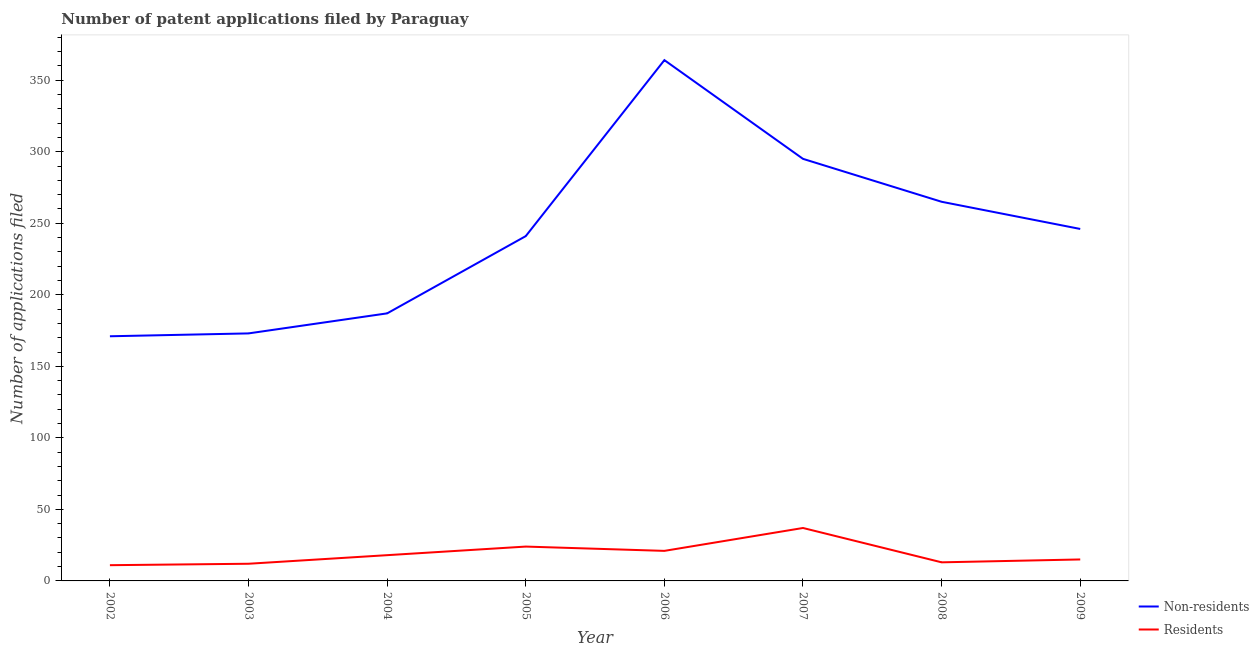What is the number of patent applications by residents in 2009?
Give a very brief answer. 15. Across all years, what is the maximum number of patent applications by non residents?
Provide a succinct answer. 364. Across all years, what is the minimum number of patent applications by non residents?
Offer a very short reply. 171. What is the total number of patent applications by residents in the graph?
Provide a short and direct response. 151. What is the difference between the number of patent applications by residents in 2002 and that in 2005?
Ensure brevity in your answer.  -13. What is the difference between the number of patent applications by non residents in 2006 and the number of patent applications by residents in 2005?
Give a very brief answer. 340. What is the average number of patent applications by residents per year?
Keep it short and to the point. 18.88. In the year 2003, what is the difference between the number of patent applications by residents and number of patent applications by non residents?
Your answer should be very brief. -161. In how many years, is the number of patent applications by residents greater than 140?
Your answer should be compact. 0. What is the ratio of the number of patent applications by residents in 2004 to that in 2006?
Offer a very short reply. 0.86. Is the difference between the number of patent applications by non residents in 2005 and 2006 greater than the difference between the number of patent applications by residents in 2005 and 2006?
Keep it short and to the point. No. What is the difference between the highest and the lowest number of patent applications by non residents?
Keep it short and to the point. 193. Does the number of patent applications by non residents monotonically increase over the years?
Offer a very short reply. No. Is the number of patent applications by non residents strictly greater than the number of patent applications by residents over the years?
Your answer should be compact. Yes. Is the number of patent applications by residents strictly less than the number of patent applications by non residents over the years?
Ensure brevity in your answer.  Yes. How many years are there in the graph?
Provide a short and direct response. 8. What is the difference between two consecutive major ticks on the Y-axis?
Provide a short and direct response. 50. How are the legend labels stacked?
Your answer should be very brief. Vertical. What is the title of the graph?
Give a very brief answer. Number of patent applications filed by Paraguay. What is the label or title of the X-axis?
Your answer should be compact. Year. What is the label or title of the Y-axis?
Ensure brevity in your answer.  Number of applications filed. What is the Number of applications filed in Non-residents in 2002?
Offer a very short reply. 171. What is the Number of applications filed of Non-residents in 2003?
Your response must be concise. 173. What is the Number of applications filed of Non-residents in 2004?
Ensure brevity in your answer.  187. What is the Number of applications filed of Non-residents in 2005?
Your response must be concise. 241. What is the Number of applications filed in Non-residents in 2006?
Give a very brief answer. 364. What is the Number of applications filed in Non-residents in 2007?
Keep it short and to the point. 295. What is the Number of applications filed in Residents in 2007?
Make the answer very short. 37. What is the Number of applications filed in Non-residents in 2008?
Your answer should be very brief. 265. What is the Number of applications filed in Residents in 2008?
Keep it short and to the point. 13. What is the Number of applications filed of Non-residents in 2009?
Your response must be concise. 246. Across all years, what is the maximum Number of applications filed in Non-residents?
Offer a terse response. 364. Across all years, what is the minimum Number of applications filed of Non-residents?
Give a very brief answer. 171. What is the total Number of applications filed in Non-residents in the graph?
Make the answer very short. 1942. What is the total Number of applications filed of Residents in the graph?
Provide a short and direct response. 151. What is the difference between the Number of applications filed in Non-residents in 2002 and that in 2003?
Provide a succinct answer. -2. What is the difference between the Number of applications filed of Residents in 2002 and that in 2003?
Ensure brevity in your answer.  -1. What is the difference between the Number of applications filed of Non-residents in 2002 and that in 2004?
Offer a terse response. -16. What is the difference between the Number of applications filed in Non-residents in 2002 and that in 2005?
Provide a short and direct response. -70. What is the difference between the Number of applications filed in Residents in 2002 and that in 2005?
Keep it short and to the point. -13. What is the difference between the Number of applications filed in Non-residents in 2002 and that in 2006?
Keep it short and to the point. -193. What is the difference between the Number of applications filed of Non-residents in 2002 and that in 2007?
Your answer should be compact. -124. What is the difference between the Number of applications filed of Non-residents in 2002 and that in 2008?
Offer a terse response. -94. What is the difference between the Number of applications filed in Residents in 2002 and that in 2008?
Provide a succinct answer. -2. What is the difference between the Number of applications filed in Non-residents in 2002 and that in 2009?
Your answer should be very brief. -75. What is the difference between the Number of applications filed of Residents in 2002 and that in 2009?
Your answer should be very brief. -4. What is the difference between the Number of applications filed of Residents in 2003 and that in 2004?
Offer a terse response. -6. What is the difference between the Number of applications filed of Non-residents in 2003 and that in 2005?
Provide a short and direct response. -68. What is the difference between the Number of applications filed of Non-residents in 2003 and that in 2006?
Offer a very short reply. -191. What is the difference between the Number of applications filed of Non-residents in 2003 and that in 2007?
Your answer should be very brief. -122. What is the difference between the Number of applications filed in Non-residents in 2003 and that in 2008?
Your answer should be very brief. -92. What is the difference between the Number of applications filed in Non-residents in 2003 and that in 2009?
Your response must be concise. -73. What is the difference between the Number of applications filed of Non-residents in 2004 and that in 2005?
Make the answer very short. -54. What is the difference between the Number of applications filed in Residents in 2004 and that in 2005?
Offer a very short reply. -6. What is the difference between the Number of applications filed in Non-residents in 2004 and that in 2006?
Ensure brevity in your answer.  -177. What is the difference between the Number of applications filed of Non-residents in 2004 and that in 2007?
Ensure brevity in your answer.  -108. What is the difference between the Number of applications filed in Residents in 2004 and that in 2007?
Your answer should be compact. -19. What is the difference between the Number of applications filed in Non-residents in 2004 and that in 2008?
Provide a short and direct response. -78. What is the difference between the Number of applications filed of Residents in 2004 and that in 2008?
Provide a short and direct response. 5. What is the difference between the Number of applications filed of Non-residents in 2004 and that in 2009?
Offer a terse response. -59. What is the difference between the Number of applications filed of Non-residents in 2005 and that in 2006?
Keep it short and to the point. -123. What is the difference between the Number of applications filed in Non-residents in 2005 and that in 2007?
Keep it short and to the point. -54. What is the difference between the Number of applications filed of Residents in 2005 and that in 2007?
Offer a terse response. -13. What is the difference between the Number of applications filed in Non-residents in 2005 and that in 2008?
Ensure brevity in your answer.  -24. What is the difference between the Number of applications filed of Residents in 2005 and that in 2008?
Provide a short and direct response. 11. What is the difference between the Number of applications filed in Residents in 2005 and that in 2009?
Offer a very short reply. 9. What is the difference between the Number of applications filed in Non-residents in 2006 and that in 2007?
Keep it short and to the point. 69. What is the difference between the Number of applications filed in Non-residents in 2006 and that in 2008?
Ensure brevity in your answer.  99. What is the difference between the Number of applications filed in Non-residents in 2006 and that in 2009?
Offer a very short reply. 118. What is the difference between the Number of applications filed in Non-residents in 2007 and that in 2009?
Offer a very short reply. 49. What is the difference between the Number of applications filed in Non-residents in 2008 and that in 2009?
Offer a terse response. 19. What is the difference between the Number of applications filed in Residents in 2008 and that in 2009?
Provide a succinct answer. -2. What is the difference between the Number of applications filed of Non-residents in 2002 and the Number of applications filed of Residents in 2003?
Your answer should be very brief. 159. What is the difference between the Number of applications filed of Non-residents in 2002 and the Number of applications filed of Residents in 2004?
Provide a succinct answer. 153. What is the difference between the Number of applications filed in Non-residents in 2002 and the Number of applications filed in Residents in 2005?
Your answer should be very brief. 147. What is the difference between the Number of applications filed in Non-residents in 2002 and the Number of applications filed in Residents in 2006?
Make the answer very short. 150. What is the difference between the Number of applications filed in Non-residents in 2002 and the Number of applications filed in Residents in 2007?
Your answer should be compact. 134. What is the difference between the Number of applications filed in Non-residents in 2002 and the Number of applications filed in Residents in 2008?
Offer a terse response. 158. What is the difference between the Number of applications filed in Non-residents in 2002 and the Number of applications filed in Residents in 2009?
Your answer should be very brief. 156. What is the difference between the Number of applications filed of Non-residents in 2003 and the Number of applications filed of Residents in 2004?
Make the answer very short. 155. What is the difference between the Number of applications filed in Non-residents in 2003 and the Number of applications filed in Residents in 2005?
Give a very brief answer. 149. What is the difference between the Number of applications filed of Non-residents in 2003 and the Number of applications filed of Residents in 2006?
Provide a short and direct response. 152. What is the difference between the Number of applications filed of Non-residents in 2003 and the Number of applications filed of Residents in 2007?
Your response must be concise. 136. What is the difference between the Number of applications filed in Non-residents in 2003 and the Number of applications filed in Residents in 2008?
Offer a very short reply. 160. What is the difference between the Number of applications filed in Non-residents in 2003 and the Number of applications filed in Residents in 2009?
Keep it short and to the point. 158. What is the difference between the Number of applications filed in Non-residents in 2004 and the Number of applications filed in Residents in 2005?
Your response must be concise. 163. What is the difference between the Number of applications filed of Non-residents in 2004 and the Number of applications filed of Residents in 2006?
Provide a short and direct response. 166. What is the difference between the Number of applications filed of Non-residents in 2004 and the Number of applications filed of Residents in 2007?
Give a very brief answer. 150. What is the difference between the Number of applications filed in Non-residents in 2004 and the Number of applications filed in Residents in 2008?
Give a very brief answer. 174. What is the difference between the Number of applications filed in Non-residents in 2004 and the Number of applications filed in Residents in 2009?
Provide a short and direct response. 172. What is the difference between the Number of applications filed of Non-residents in 2005 and the Number of applications filed of Residents in 2006?
Your response must be concise. 220. What is the difference between the Number of applications filed of Non-residents in 2005 and the Number of applications filed of Residents in 2007?
Make the answer very short. 204. What is the difference between the Number of applications filed of Non-residents in 2005 and the Number of applications filed of Residents in 2008?
Provide a succinct answer. 228. What is the difference between the Number of applications filed in Non-residents in 2005 and the Number of applications filed in Residents in 2009?
Make the answer very short. 226. What is the difference between the Number of applications filed in Non-residents in 2006 and the Number of applications filed in Residents in 2007?
Your response must be concise. 327. What is the difference between the Number of applications filed in Non-residents in 2006 and the Number of applications filed in Residents in 2008?
Your response must be concise. 351. What is the difference between the Number of applications filed in Non-residents in 2006 and the Number of applications filed in Residents in 2009?
Provide a short and direct response. 349. What is the difference between the Number of applications filed in Non-residents in 2007 and the Number of applications filed in Residents in 2008?
Make the answer very short. 282. What is the difference between the Number of applications filed in Non-residents in 2007 and the Number of applications filed in Residents in 2009?
Give a very brief answer. 280. What is the difference between the Number of applications filed of Non-residents in 2008 and the Number of applications filed of Residents in 2009?
Make the answer very short. 250. What is the average Number of applications filed in Non-residents per year?
Ensure brevity in your answer.  242.75. What is the average Number of applications filed in Residents per year?
Provide a succinct answer. 18.88. In the year 2002, what is the difference between the Number of applications filed in Non-residents and Number of applications filed in Residents?
Your response must be concise. 160. In the year 2003, what is the difference between the Number of applications filed in Non-residents and Number of applications filed in Residents?
Your answer should be very brief. 161. In the year 2004, what is the difference between the Number of applications filed in Non-residents and Number of applications filed in Residents?
Provide a short and direct response. 169. In the year 2005, what is the difference between the Number of applications filed of Non-residents and Number of applications filed of Residents?
Ensure brevity in your answer.  217. In the year 2006, what is the difference between the Number of applications filed in Non-residents and Number of applications filed in Residents?
Your response must be concise. 343. In the year 2007, what is the difference between the Number of applications filed of Non-residents and Number of applications filed of Residents?
Your answer should be very brief. 258. In the year 2008, what is the difference between the Number of applications filed of Non-residents and Number of applications filed of Residents?
Give a very brief answer. 252. In the year 2009, what is the difference between the Number of applications filed in Non-residents and Number of applications filed in Residents?
Your answer should be compact. 231. What is the ratio of the Number of applications filed in Non-residents in 2002 to that in 2003?
Your answer should be very brief. 0.99. What is the ratio of the Number of applications filed in Non-residents in 2002 to that in 2004?
Offer a terse response. 0.91. What is the ratio of the Number of applications filed of Residents in 2002 to that in 2004?
Provide a succinct answer. 0.61. What is the ratio of the Number of applications filed in Non-residents in 2002 to that in 2005?
Offer a very short reply. 0.71. What is the ratio of the Number of applications filed of Residents in 2002 to that in 2005?
Your answer should be compact. 0.46. What is the ratio of the Number of applications filed in Non-residents in 2002 to that in 2006?
Your answer should be very brief. 0.47. What is the ratio of the Number of applications filed in Residents in 2002 to that in 2006?
Give a very brief answer. 0.52. What is the ratio of the Number of applications filed in Non-residents in 2002 to that in 2007?
Offer a terse response. 0.58. What is the ratio of the Number of applications filed of Residents in 2002 to that in 2007?
Offer a very short reply. 0.3. What is the ratio of the Number of applications filed of Non-residents in 2002 to that in 2008?
Your answer should be very brief. 0.65. What is the ratio of the Number of applications filed in Residents in 2002 to that in 2008?
Give a very brief answer. 0.85. What is the ratio of the Number of applications filed in Non-residents in 2002 to that in 2009?
Your answer should be compact. 0.7. What is the ratio of the Number of applications filed of Residents in 2002 to that in 2009?
Keep it short and to the point. 0.73. What is the ratio of the Number of applications filed in Non-residents in 2003 to that in 2004?
Provide a succinct answer. 0.93. What is the ratio of the Number of applications filed of Non-residents in 2003 to that in 2005?
Make the answer very short. 0.72. What is the ratio of the Number of applications filed in Residents in 2003 to that in 2005?
Your answer should be compact. 0.5. What is the ratio of the Number of applications filed in Non-residents in 2003 to that in 2006?
Offer a very short reply. 0.48. What is the ratio of the Number of applications filed in Non-residents in 2003 to that in 2007?
Keep it short and to the point. 0.59. What is the ratio of the Number of applications filed of Residents in 2003 to that in 2007?
Your answer should be compact. 0.32. What is the ratio of the Number of applications filed in Non-residents in 2003 to that in 2008?
Offer a very short reply. 0.65. What is the ratio of the Number of applications filed in Non-residents in 2003 to that in 2009?
Provide a succinct answer. 0.7. What is the ratio of the Number of applications filed of Non-residents in 2004 to that in 2005?
Offer a very short reply. 0.78. What is the ratio of the Number of applications filed in Non-residents in 2004 to that in 2006?
Your answer should be compact. 0.51. What is the ratio of the Number of applications filed of Non-residents in 2004 to that in 2007?
Keep it short and to the point. 0.63. What is the ratio of the Number of applications filed in Residents in 2004 to that in 2007?
Offer a very short reply. 0.49. What is the ratio of the Number of applications filed of Non-residents in 2004 to that in 2008?
Your answer should be compact. 0.71. What is the ratio of the Number of applications filed in Residents in 2004 to that in 2008?
Keep it short and to the point. 1.38. What is the ratio of the Number of applications filed in Non-residents in 2004 to that in 2009?
Ensure brevity in your answer.  0.76. What is the ratio of the Number of applications filed of Non-residents in 2005 to that in 2006?
Keep it short and to the point. 0.66. What is the ratio of the Number of applications filed in Residents in 2005 to that in 2006?
Provide a short and direct response. 1.14. What is the ratio of the Number of applications filed in Non-residents in 2005 to that in 2007?
Make the answer very short. 0.82. What is the ratio of the Number of applications filed in Residents in 2005 to that in 2007?
Give a very brief answer. 0.65. What is the ratio of the Number of applications filed in Non-residents in 2005 to that in 2008?
Provide a succinct answer. 0.91. What is the ratio of the Number of applications filed in Residents in 2005 to that in 2008?
Provide a succinct answer. 1.85. What is the ratio of the Number of applications filed in Non-residents in 2005 to that in 2009?
Ensure brevity in your answer.  0.98. What is the ratio of the Number of applications filed of Residents in 2005 to that in 2009?
Keep it short and to the point. 1.6. What is the ratio of the Number of applications filed of Non-residents in 2006 to that in 2007?
Your response must be concise. 1.23. What is the ratio of the Number of applications filed of Residents in 2006 to that in 2007?
Offer a very short reply. 0.57. What is the ratio of the Number of applications filed in Non-residents in 2006 to that in 2008?
Your answer should be compact. 1.37. What is the ratio of the Number of applications filed of Residents in 2006 to that in 2008?
Offer a terse response. 1.62. What is the ratio of the Number of applications filed of Non-residents in 2006 to that in 2009?
Ensure brevity in your answer.  1.48. What is the ratio of the Number of applications filed of Non-residents in 2007 to that in 2008?
Offer a terse response. 1.11. What is the ratio of the Number of applications filed in Residents in 2007 to that in 2008?
Your answer should be very brief. 2.85. What is the ratio of the Number of applications filed of Non-residents in 2007 to that in 2009?
Offer a very short reply. 1.2. What is the ratio of the Number of applications filed of Residents in 2007 to that in 2009?
Provide a short and direct response. 2.47. What is the ratio of the Number of applications filed in Non-residents in 2008 to that in 2009?
Provide a short and direct response. 1.08. What is the ratio of the Number of applications filed in Residents in 2008 to that in 2009?
Provide a succinct answer. 0.87. What is the difference between the highest and the second highest Number of applications filed of Non-residents?
Make the answer very short. 69. What is the difference between the highest and the lowest Number of applications filed in Non-residents?
Provide a short and direct response. 193. What is the difference between the highest and the lowest Number of applications filed of Residents?
Give a very brief answer. 26. 